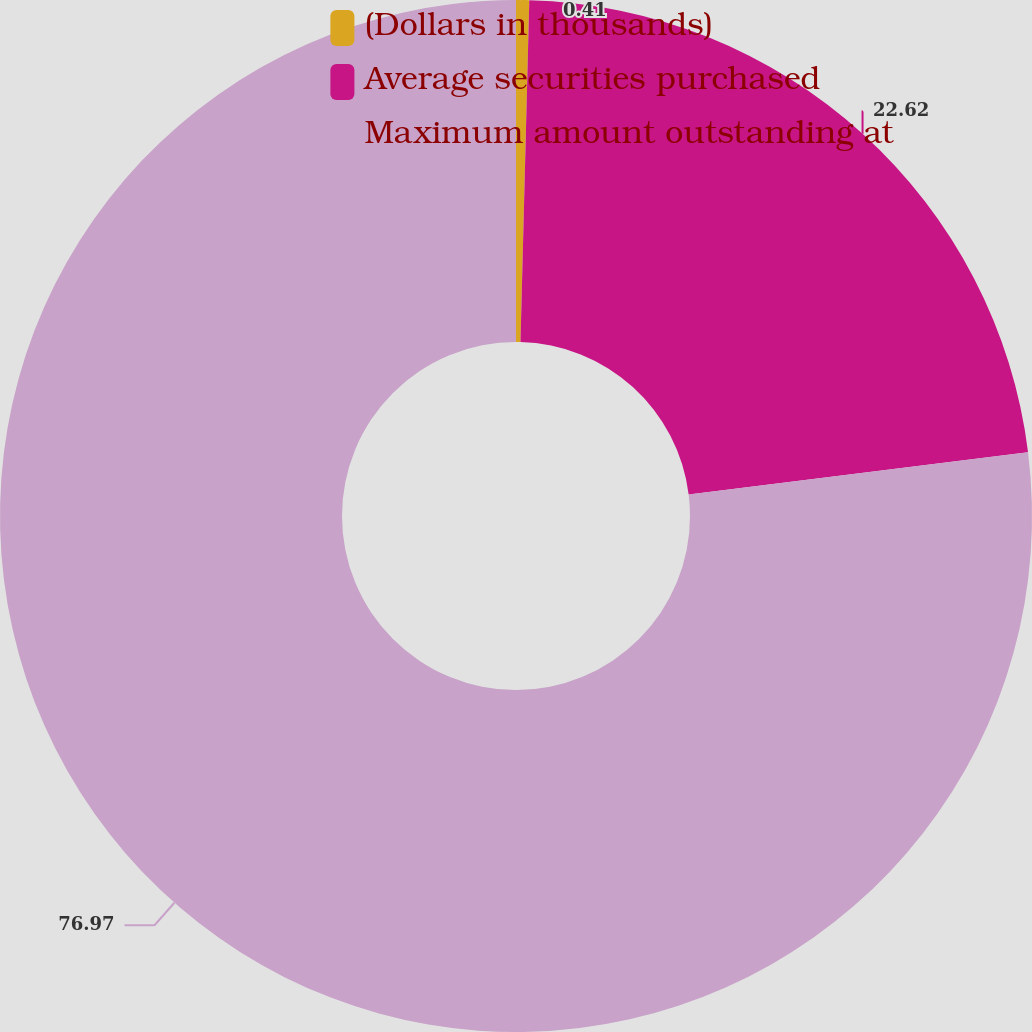Convert chart. <chart><loc_0><loc_0><loc_500><loc_500><pie_chart><fcel>(Dollars in thousands)<fcel>Average securities purchased<fcel>Maximum amount outstanding at<nl><fcel>0.41%<fcel>22.62%<fcel>76.97%<nl></chart> 